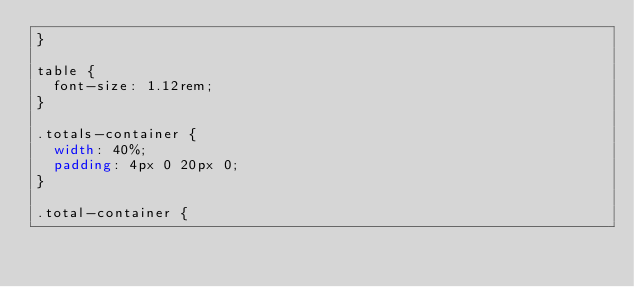Convert code to text. <code><loc_0><loc_0><loc_500><loc_500><_CSS_>}

table {
  font-size: 1.12rem;
}

.totals-container {
  width: 40%;
  padding: 4px 0 20px 0;
}

.total-container {</code> 